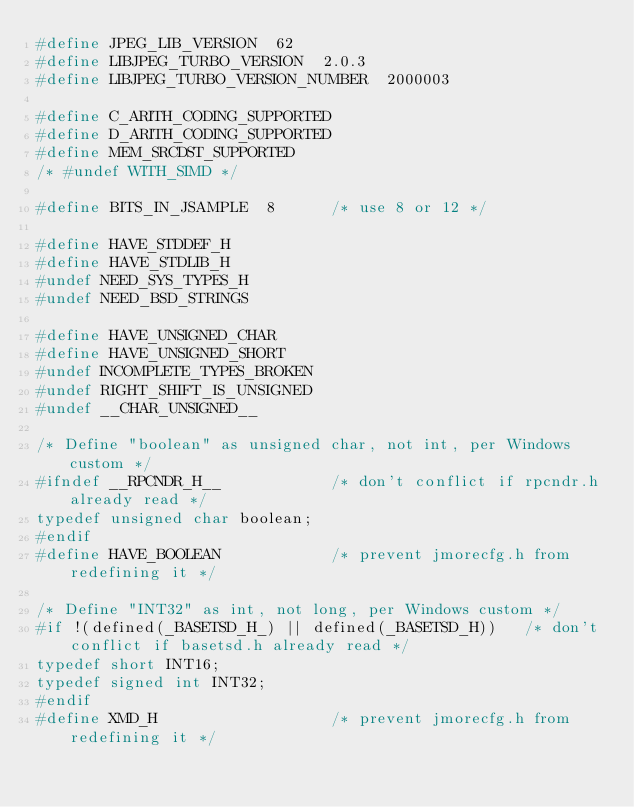Convert code to text. <code><loc_0><loc_0><loc_500><loc_500><_C_>#define JPEG_LIB_VERSION  62
#define LIBJPEG_TURBO_VERSION  2.0.3
#define LIBJPEG_TURBO_VERSION_NUMBER  2000003

#define C_ARITH_CODING_SUPPORTED
#define D_ARITH_CODING_SUPPORTED
#define MEM_SRCDST_SUPPORTED
/* #undef WITH_SIMD */

#define BITS_IN_JSAMPLE  8      /* use 8 or 12 */

#define HAVE_STDDEF_H
#define HAVE_STDLIB_H
#undef NEED_SYS_TYPES_H
#undef NEED_BSD_STRINGS

#define HAVE_UNSIGNED_CHAR
#define HAVE_UNSIGNED_SHORT
#undef INCOMPLETE_TYPES_BROKEN
#undef RIGHT_SHIFT_IS_UNSIGNED
#undef __CHAR_UNSIGNED__

/* Define "boolean" as unsigned char, not int, per Windows custom */
#ifndef __RPCNDR_H__            /* don't conflict if rpcndr.h already read */
typedef unsigned char boolean;
#endif
#define HAVE_BOOLEAN            /* prevent jmorecfg.h from redefining it */

/* Define "INT32" as int, not long, per Windows custom */
#if !(defined(_BASETSD_H_) || defined(_BASETSD_H))   /* don't conflict if basetsd.h already read */
typedef short INT16;
typedef signed int INT32;
#endif
#define XMD_H                   /* prevent jmorecfg.h from redefining it */
</code> 